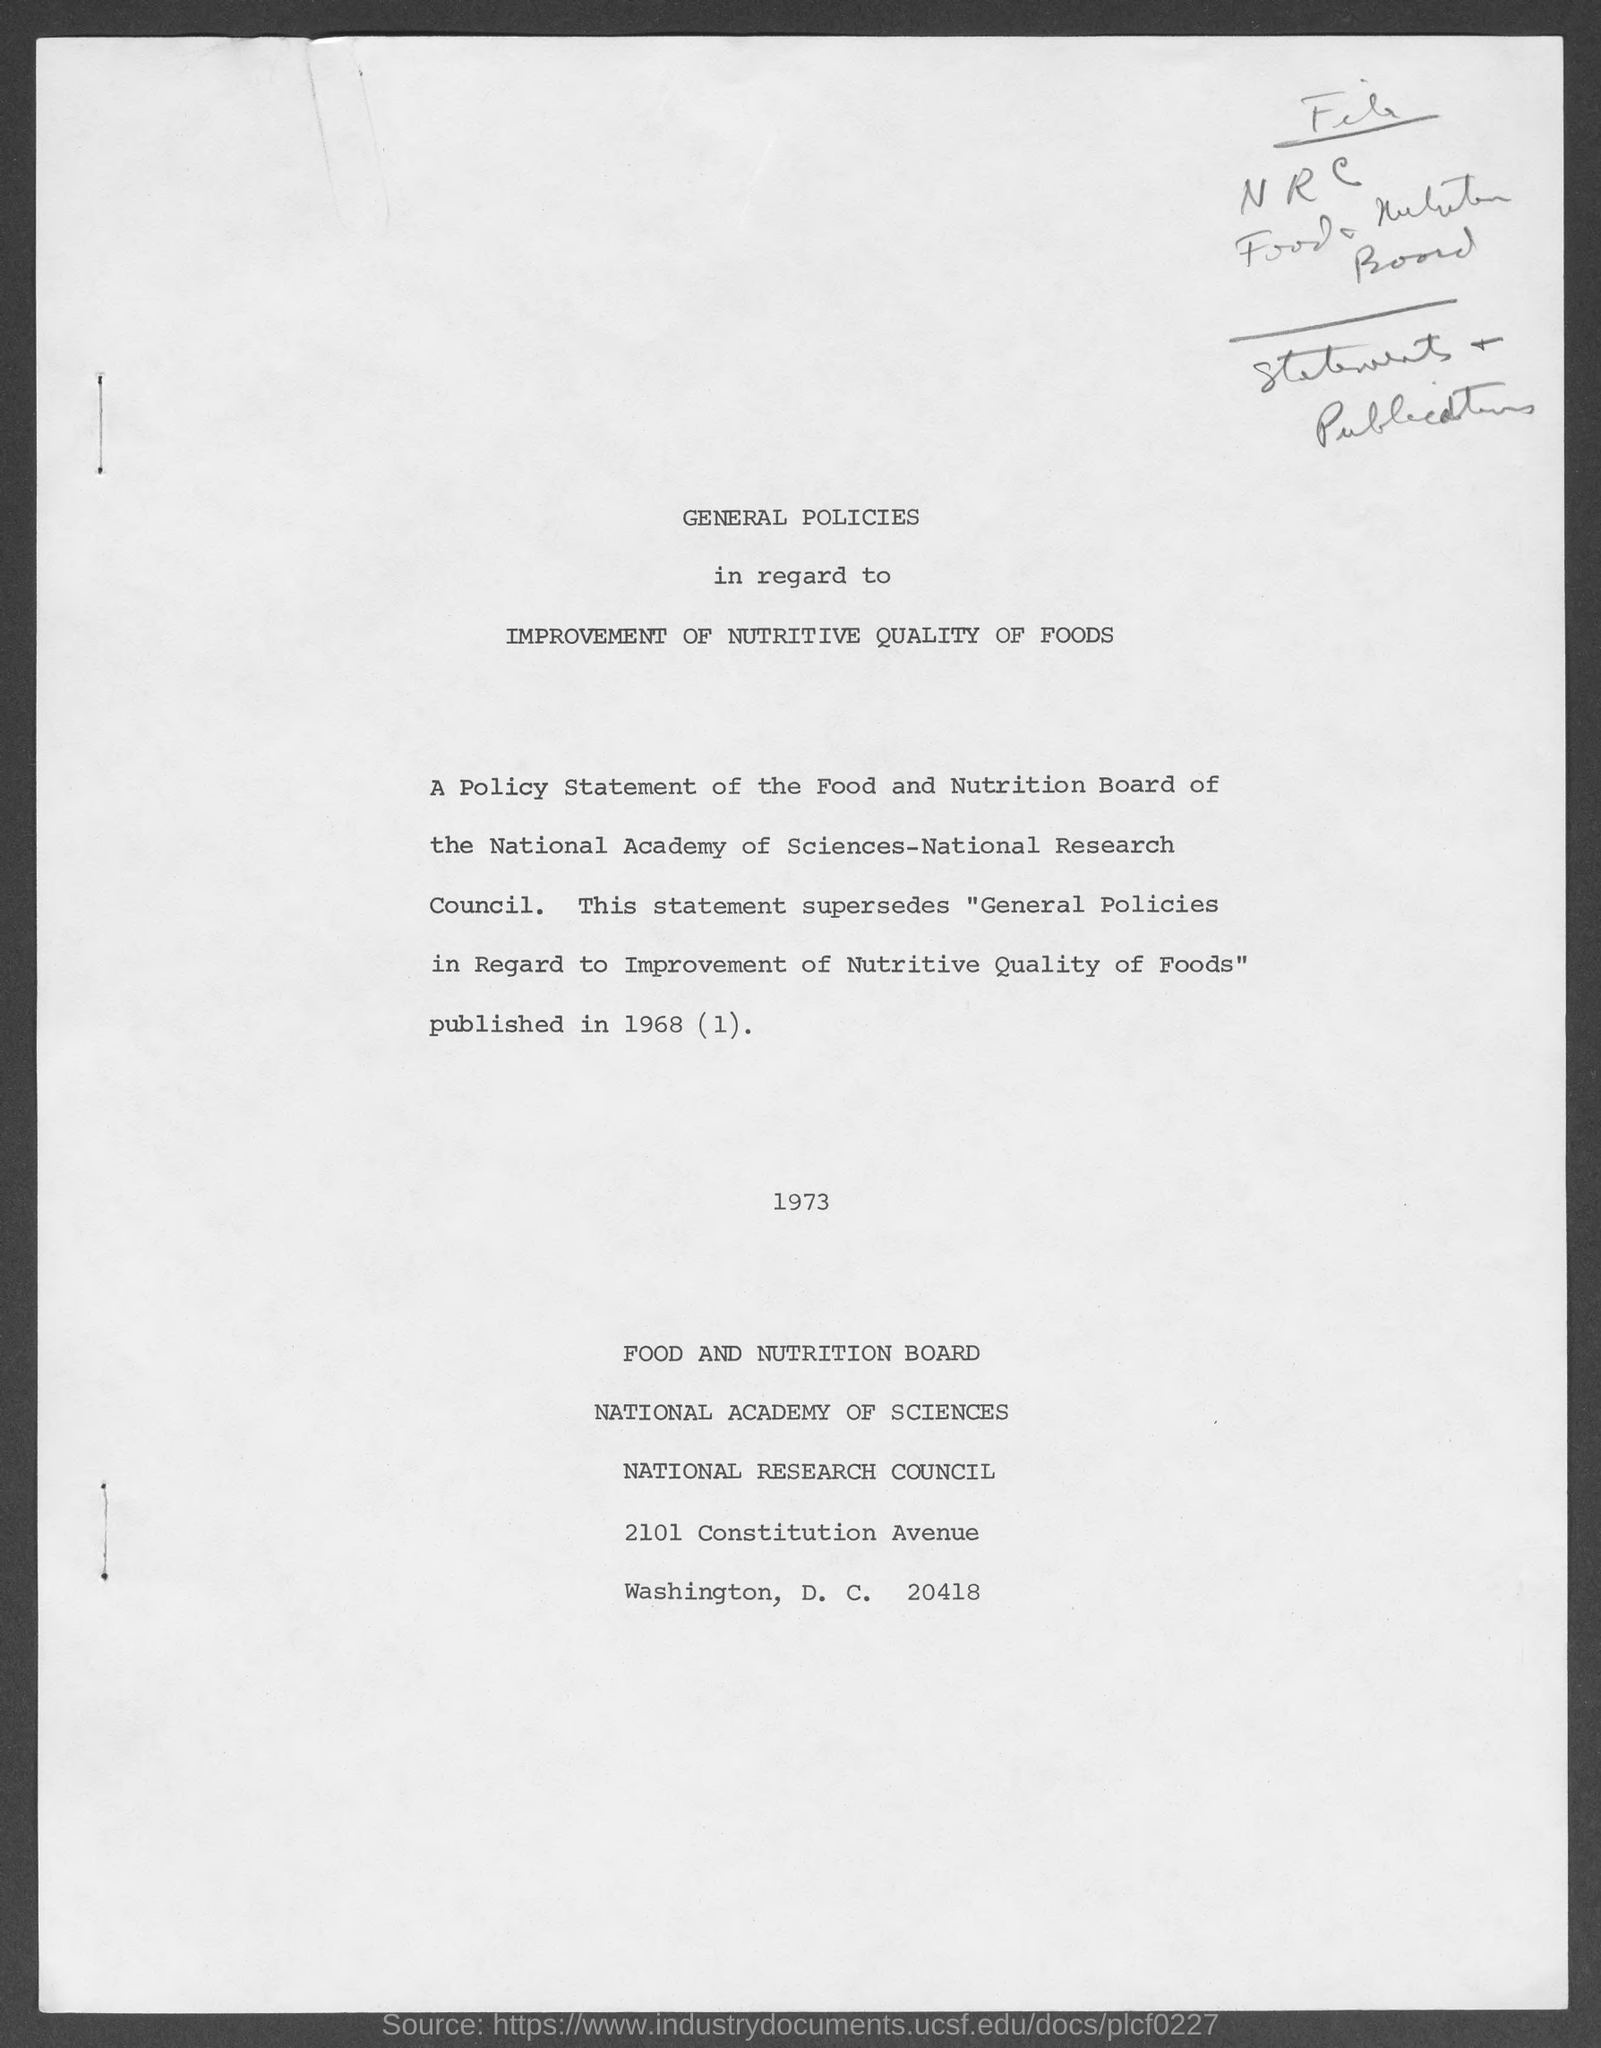List a handful of essential elements in this visual. The street address of the Food and Nutrition Board is located at 2101 Constitution Avenue. 